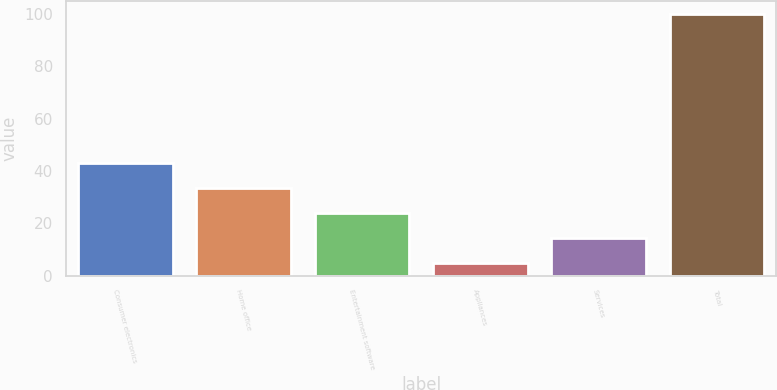Convert chart to OTSL. <chart><loc_0><loc_0><loc_500><loc_500><bar_chart><fcel>Consumer electronics<fcel>Home office<fcel>Entertainment software<fcel>Appliances<fcel>Services<fcel>Total<nl><fcel>43<fcel>33.5<fcel>24<fcel>5<fcel>14.5<fcel>100<nl></chart> 